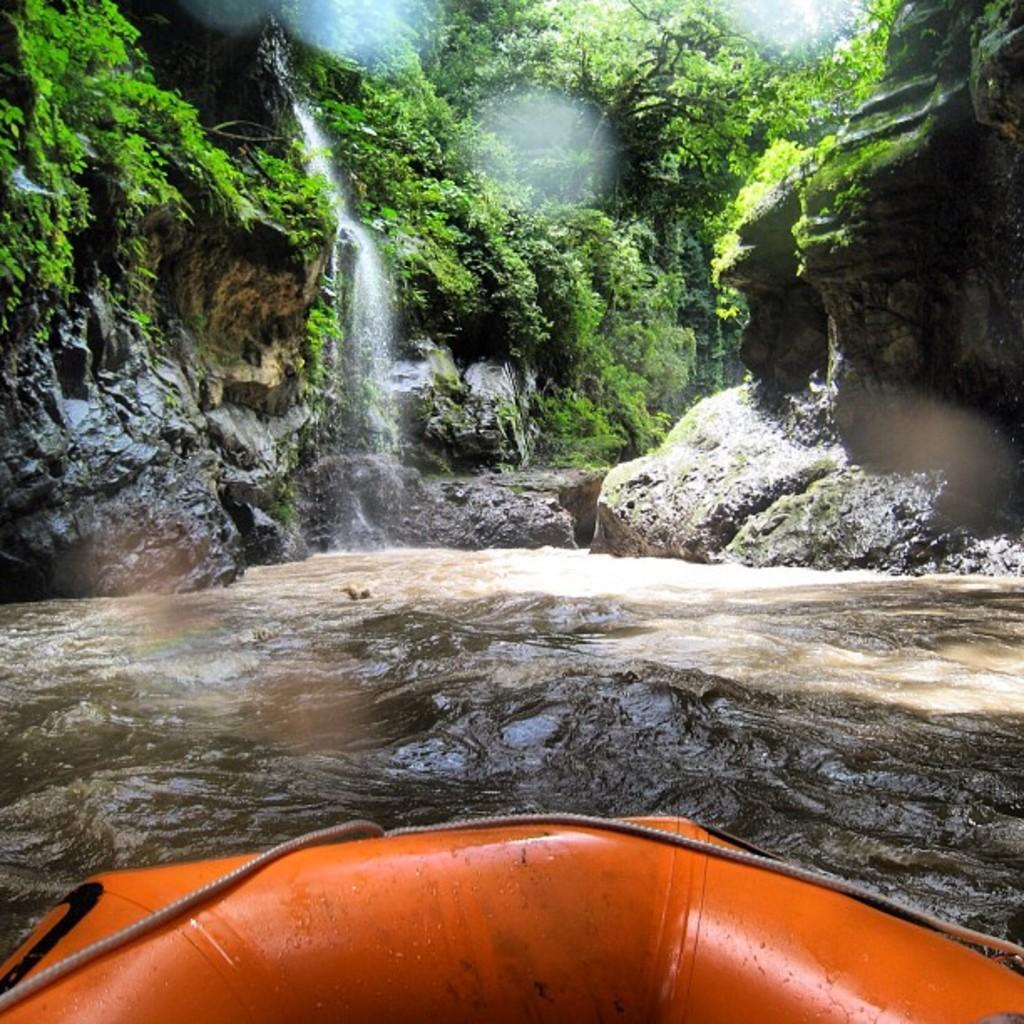What natural feature is the main subject of the image? There is a waterfall in the image. What is the primary substance visible in the image? There is water visible in the image. What type of landscape can be seen in the image? There are hills and trees in the image. What man-made object is present in the image? There is a boat in the image. What color is the ink used to write on the trees in the image? There is no ink or writing present on the trees in the image. What emotion is the waterfall feeling in the image? The image does not depict emotions, so it cannot be determined how the waterfall feels. 